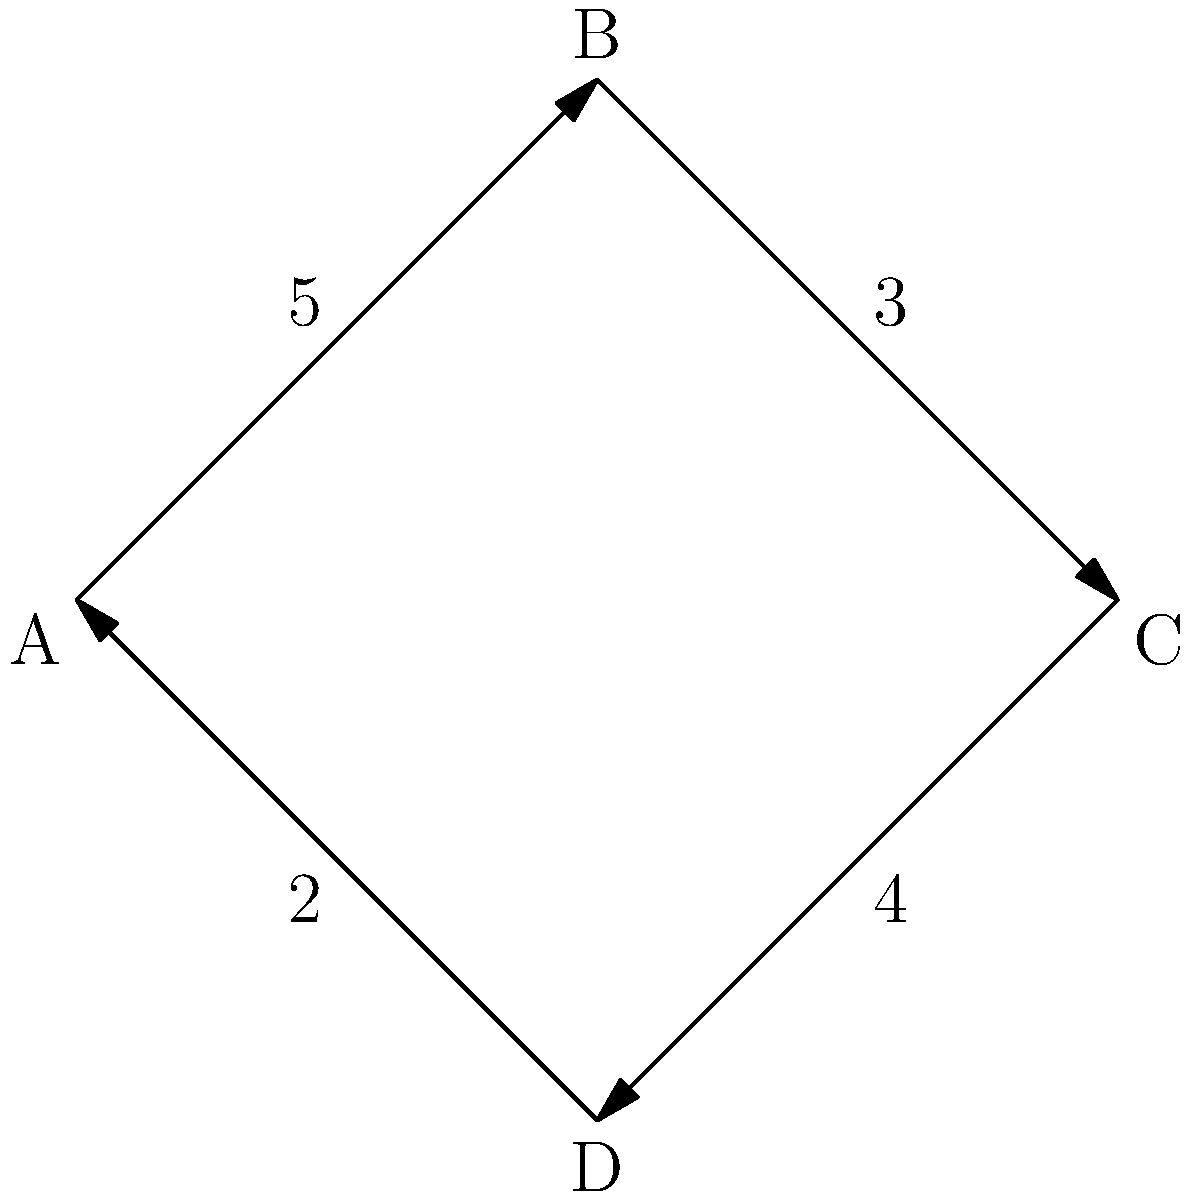Given the graph representation of an intersection where vertices represent directions (A: North, B: East, C: South, D: West) and edge weights represent the number of cars passing through per minute, what is the maximum flow of traffic that can pass through this intersection in one complete cycle, assuming no turns are allowed? To solve this problem, we need to follow these steps:

1. Understand the graph representation:
   - Vertices (A, B, C, D) represent directions (North, East, South, West)
   - Edge weights represent the number of cars passing through per minute
   - The graph shows a complete cycle of traffic flow

2. Identify the flow in each direction:
   - A to B (North to East): 5 cars/minute
   - B to C (East to South): 3 cars/minute
   - C to D (South to West): 4 cars/minute
   - D to A (West to North): 2 cars/minute

3. Determine the bottleneck:
   The maximum flow through the intersection is limited by the smallest edge weight, which is the bottleneck. In this case, the bottleneck is the edge from D to A with 2 cars/minute.

4. Calculate the maximum flow:
   Since we're looking at one complete cycle and no turns are allowed, the maximum flow is equal to the bottleneck value.

   Maximum flow = 2 cars/minute

5. Convert to cars per complete cycle:
   One complete cycle allows each direction to flow once, so the total cars passing through in one cycle is:

   Cars per cycle = Maximum flow × Number of directions
                  = 2 cars/minute × 4 directions
                  = 8 cars/cycle

Therefore, the maximum flow of traffic that can pass through this intersection in one complete cycle is 8 cars.
Answer: 8 cars 